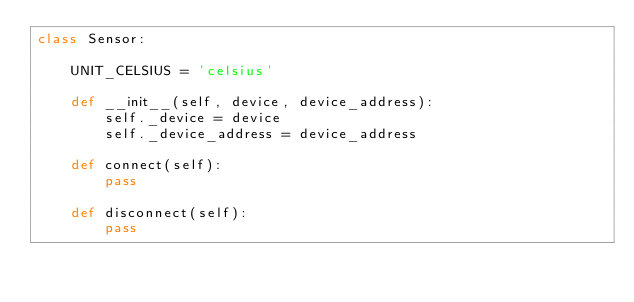Convert code to text. <code><loc_0><loc_0><loc_500><loc_500><_Python_>class Sensor:

    UNIT_CELSIUS = 'celsius'

    def __init__(self, device, device_address):
        self._device = device
        self._device_address = device_address

    def connect(self):
        pass

    def disconnect(self):
        pass
</code> 